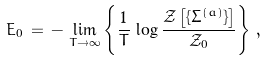<formula> <loc_0><loc_0><loc_500><loc_500>E _ { 0 } \, = \, - \, \lim _ { T \to \infty } \left \{ \frac { 1 } { T } \, \log \frac { { \mathcal { Z } } \left [ \{ \Sigma ^ { ( a ) } \} \right ] } { { \mathcal { Z } } _ { 0 } } \right \} \, ,</formula> 